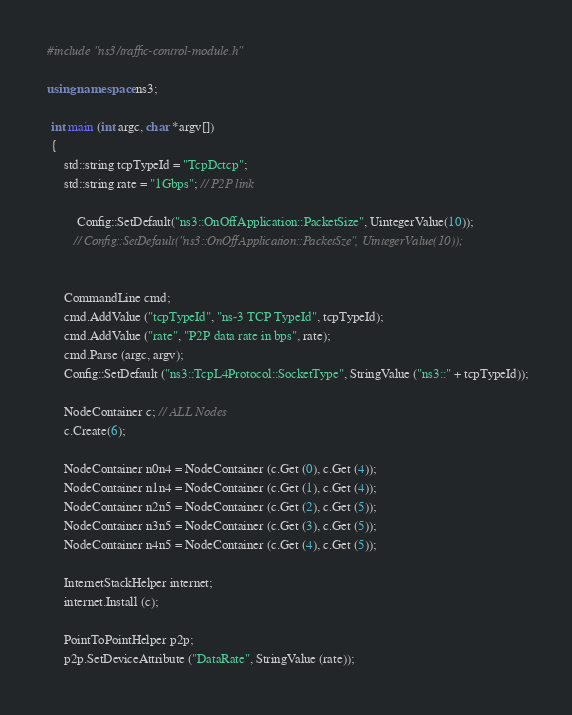<code> <loc_0><loc_0><loc_500><loc_500><_C++_> #include "ns3/traffic-control-module.h"
 
 using namespace ns3;
  
  int main (int argc, char *argv[])
  {
	  std::string tcpTypeId = "TcpDctcp";
	  std::string rate = "1Gbps"; // P2P link

          Config::SetDefault("ns3::OnOffApplication::PacketSize", UintegerValue(10));
         // Config::SetDefault("ns3::OnOffApplication::PacketSze", UintegerValue(10));

	  
	  CommandLine cmd;
      cmd.AddValue ("tcpTypeId", "ns-3 TCP TypeId", tcpTypeId);
	  cmd.AddValue ("rate", "P2P data rate in bps", rate);
	  cmd.Parse (argc, argv);
	  Config::SetDefault ("ns3::TcpL4Protocol::SocketType", StringValue ("ns3::" + tcpTypeId));
	  
	  NodeContainer c; // ALL Nodes
	  c.Create(6);

	  NodeContainer n0n4 = NodeContainer (c.Get (0), c.Get (4));
	  NodeContainer n1n4 = NodeContainer (c.Get (1), c.Get (4));
	  NodeContainer n2n5 = NodeContainer (c.Get (2), c.Get (5));
	  NodeContainer n3n5 = NodeContainer (c.Get (3), c.Get (5));
	  NodeContainer n4n5 = NodeContainer (c.Get (4), c.Get (5));
	  
	  InternetStackHelper internet;
      internet.Install (c);
	  
	  PointToPointHelper p2p;
	  p2p.SetDeviceAttribute ("DataRate", StringValue (rate));
</code> 